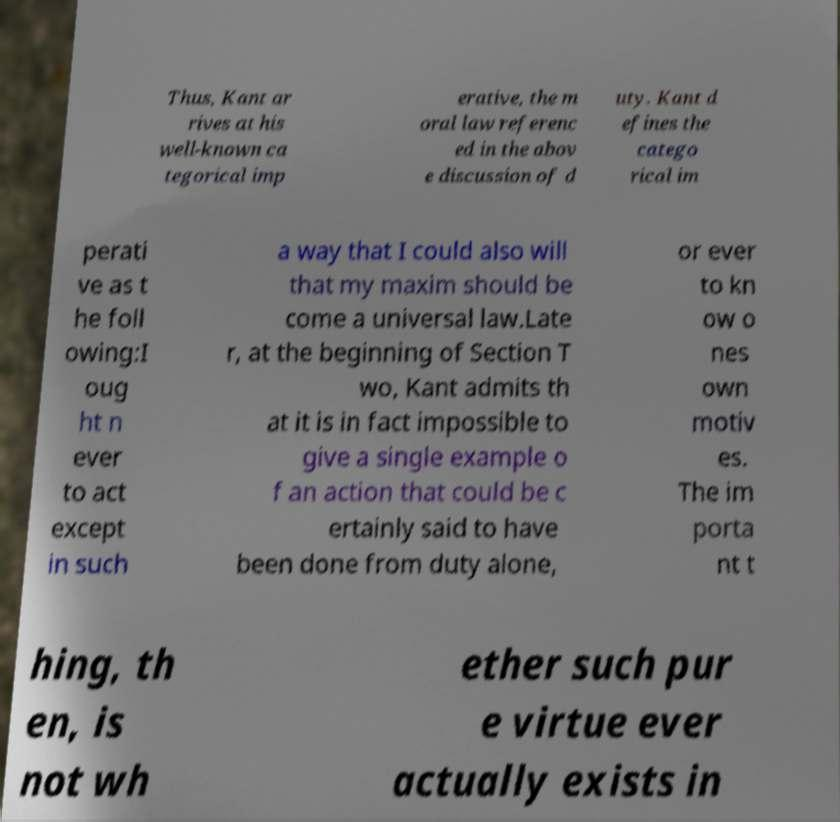Could you extract and type out the text from this image? Thus, Kant ar rives at his well-known ca tegorical imp erative, the m oral law referenc ed in the abov e discussion of d uty. Kant d efines the catego rical im perati ve as t he foll owing:I oug ht n ever to act except in such a way that I could also will that my maxim should be come a universal law.Late r, at the beginning of Section T wo, Kant admits th at it is in fact impossible to give a single example o f an action that could be c ertainly said to have been done from duty alone, or ever to kn ow o nes own motiv es. The im porta nt t hing, th en, is not wh ether such pur e virtue ever actually exists in 